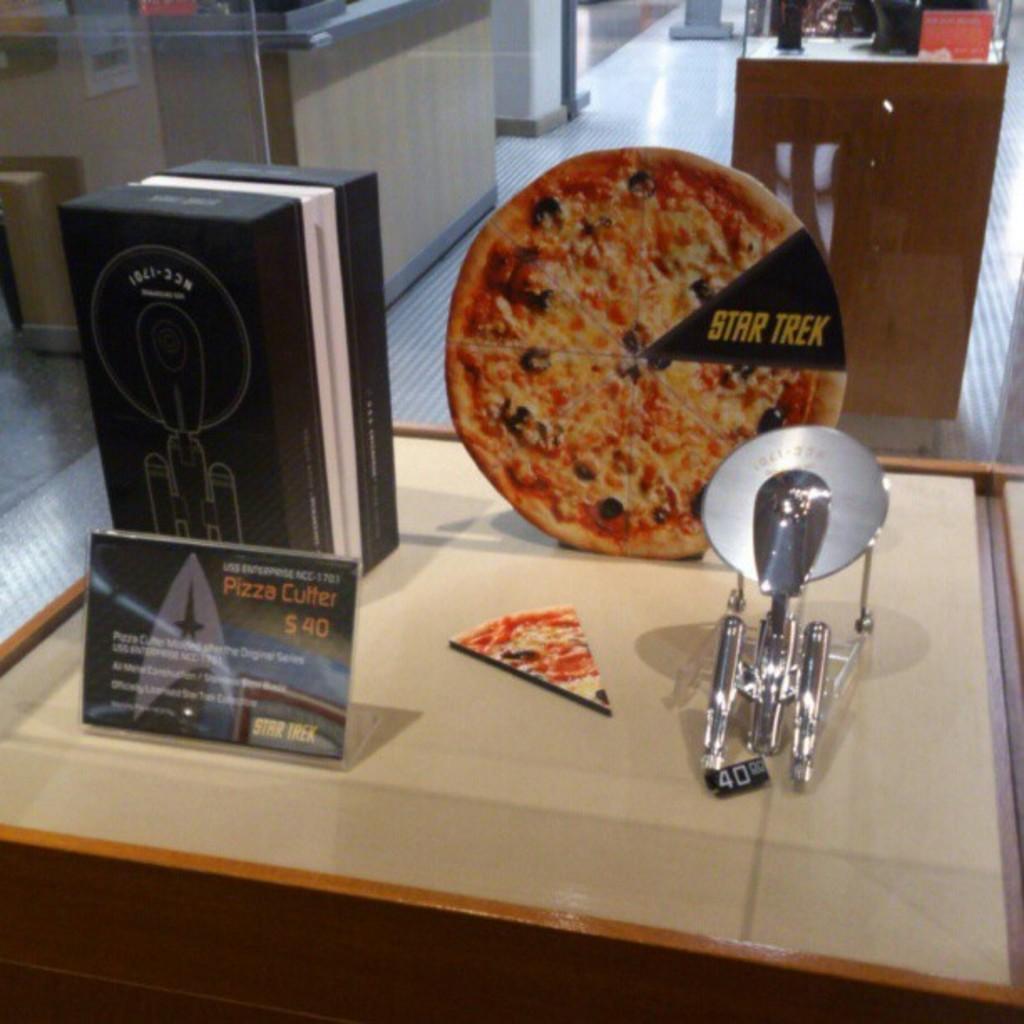Please provide a concise description of this image. In this picture there is a desk in the center of the image, on which there is a box and a pizza poster on it, there is another table at the top side of the image. 